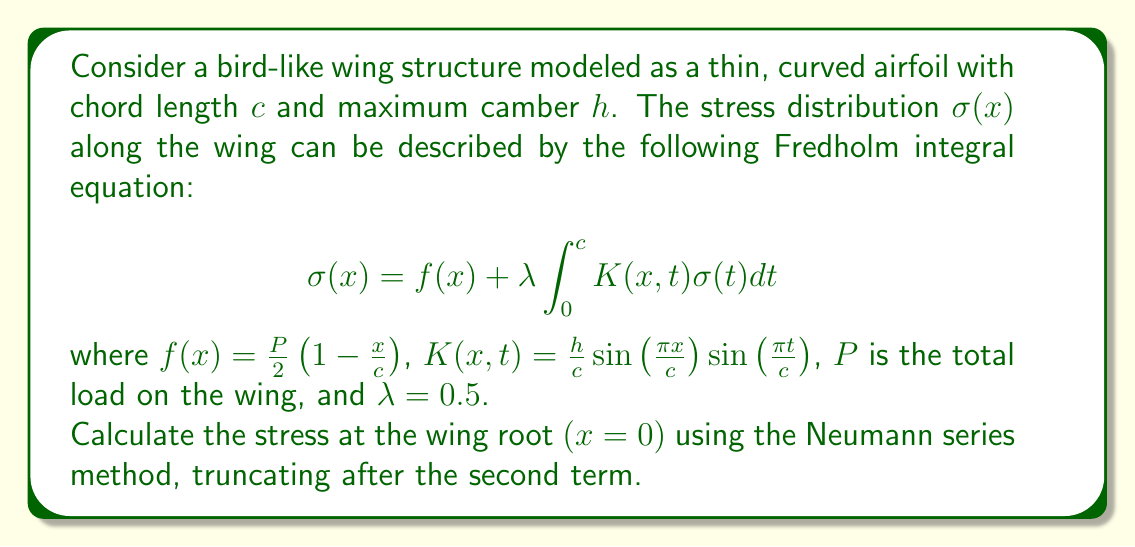Help me with this question. To solve this problem, we'll use the Neumann series method:

1) The Neumann series solution for a Fredholm integral equation is given by:
   $$\sigma(x) = f(x) + \lambda\int_0^c K(x,t)f(t)dt + \lambda^2\int_0^c\int_0^c K(x,s)K(s,t)f(t)dtds + \cdots$$

2) We'll truncate after the second term, so we need to calculate:
   $$\sigma(0) \approx f(0) + \lambda\int_0^c K(0,t)f(t)dt$$

3) First, calculate $f(0)$:
   $$f(0) = \frac{P}{2}\left(1 - \frac{0}{c}\right) = \frac{P}{2}$$

4) Now, calculate the integral term:
   $$\lambda\int_0^c K(0,t)f(t)dt = 0.5 \int_0^c \frac{h}{c}\sin\left(\frac{\pi \cdot 0}{c}\right)\sin\left(\frac{\pi t}{c}\right) \cdot \frac{P}{2}\left(1 - \frac{t}{c}\right)dt$$

5) Simplify:
   $$\lambda\int_0^c K(0,t)f(t)dt = 0.5 \cdot 0 \cdot \int_0^c \sin\left(\frac{\pi t}{c}\right) \cdot \frac{P}{2}\left(1 - \frac{t}{c}\right)dt = 0$$

6) Sum the terms:
   $$\sigma(0) \approx \frac{P}{2} + 0 = \frac{P}{2}$$

Therefore, the stress at the wing root $(x=0)$ is approximately $\frac{P}{2}$.
Answer: $\frac{P}{2}$ 